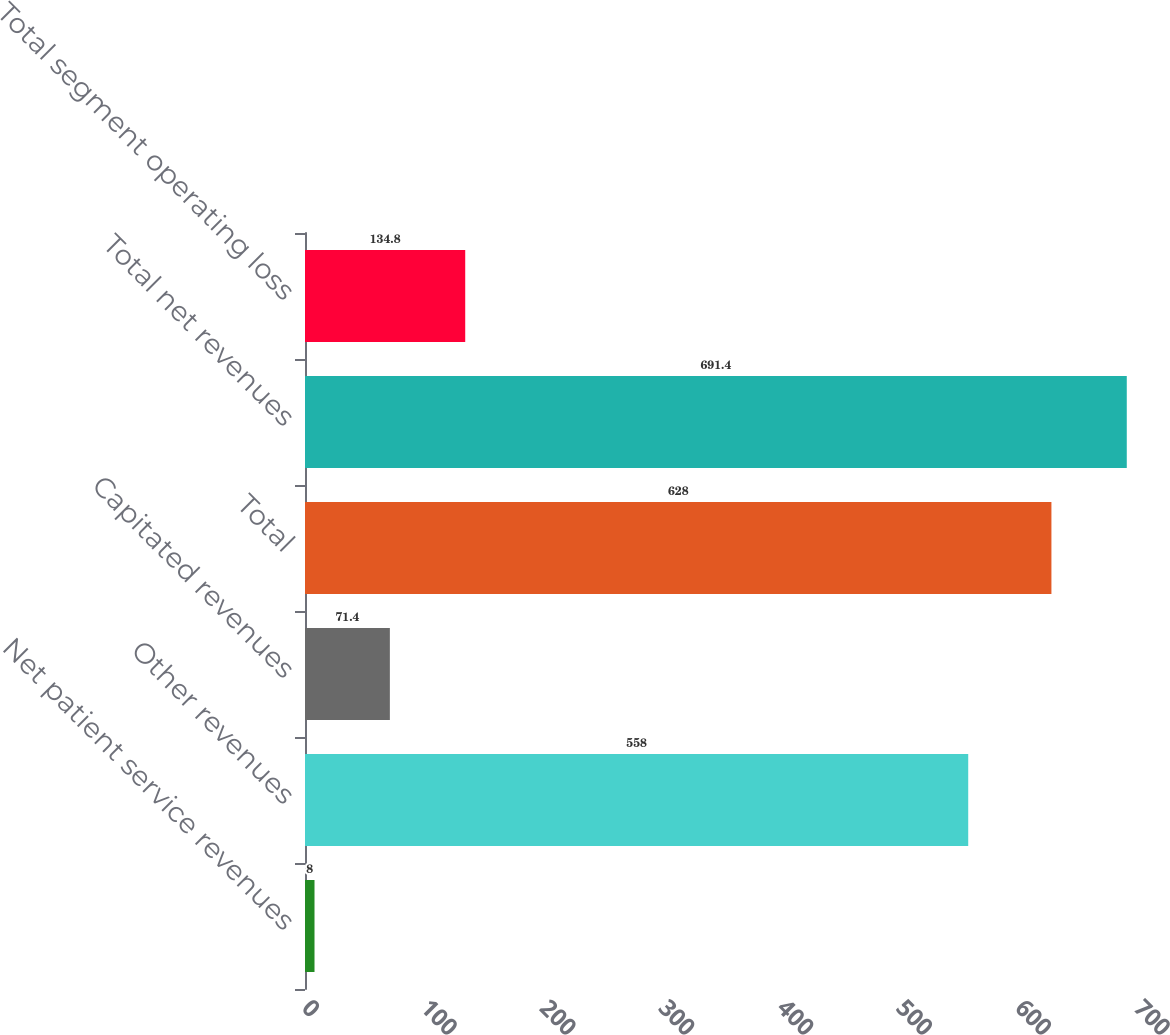Convert chart to OTSL. <chart><loc_0><loc_0><loc_500><loc_500><bar_chart><fcel>Net patient service revenues<fcel>Other revenues<fcel>Capitated revenues<fcel>Total<fcel>Total net revenues<fcel>Total segment operating loss<nl><fcel>8<fcel>558<fcel>71.4<fcel>628<fcel>691.4<fcel>134.8<nl></chart> 